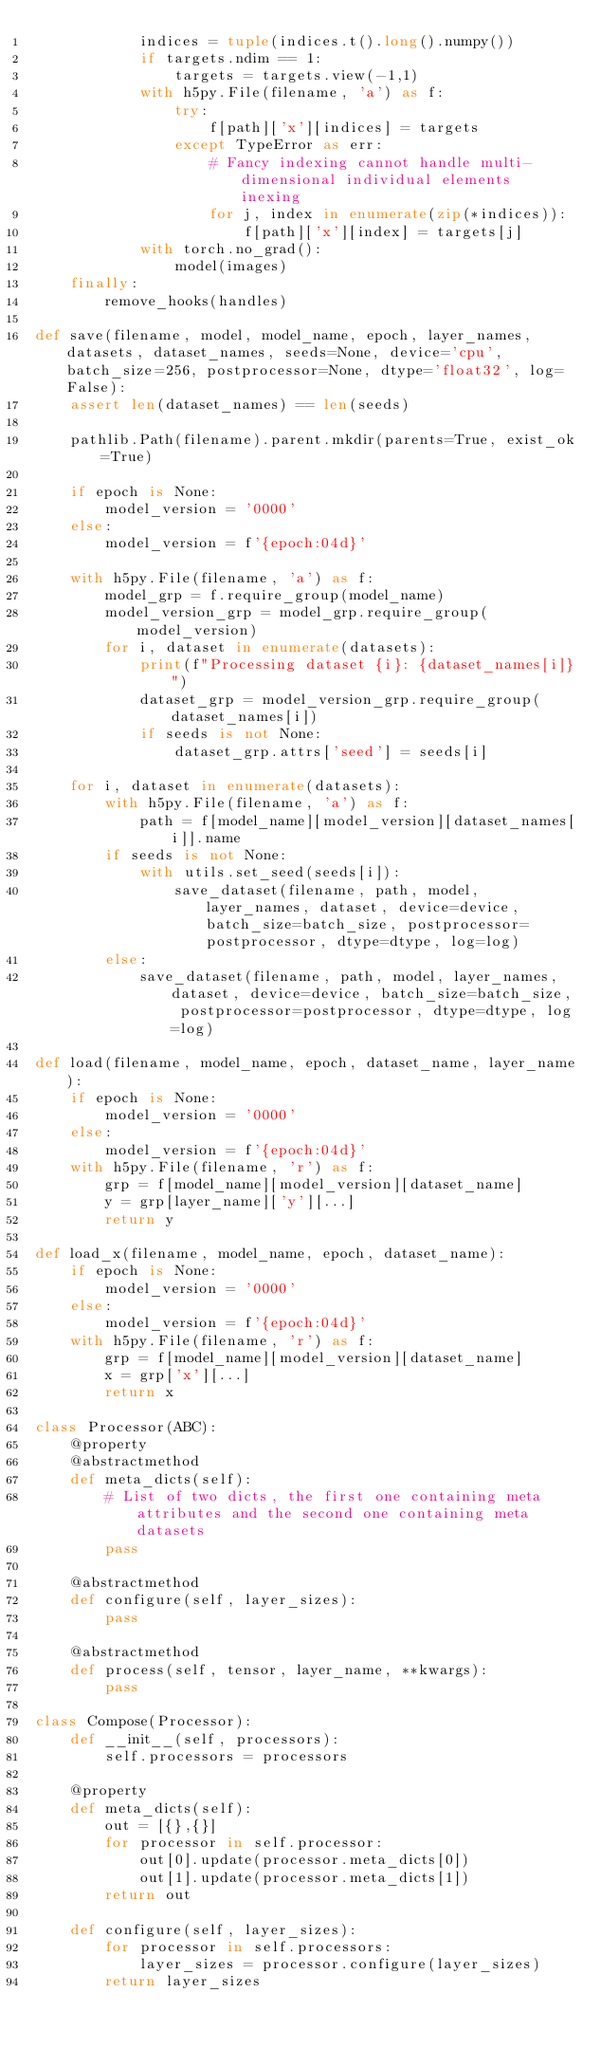<code> <loc_0><loc_0><loc_500><loc_500><_Python_>            indices = tuple(indices.t().long().numpy())
            if targets.ndim == 1:
                targets = targets.view(-1,1)
            with h5py.File(filename, 'a') as f:
                try:
                    f[path]['x'][indices] = targets
                except TypeError as err:
                    # Fancy indexing cannot handle multi-dimensional individual elements inexing
                    for j, index in enumerate(zip(*indices)):
                        f[path]['x'][index] = targets[j]
            with torch.no_grad():
                model(images)
    finally:
        remove_hooks(handles)
            
def save(filename, model, model_name, epoch, layer_names, datasets, dataset_names, seeds=None, device='cpu', batch_size=256, postprocessor=None, dtype='float32', log=False):
    assert len(dataset_names) == len(seeds)
    
    pathlib.Path(filename).parent.mkdir(parents=True, exist_ok=True)
    
    if epoch is None:
        model_version = '0000'
    else:
        model_version = f'{epoch:04d}'
    
    with h5py.File(filename, 'a') as f:
        model_grp = f.require_group(model_name)
        model_version_grp = model_grp.require_group(model_version)
        for i, dataset in enumerate(datasets):
            print(f"Processing dataset {i}: {dataset_names[i]}")
            dataset_grp = model_version_grp.require_group(dataset_names[i])
            if seeds is not None:
                dataset_grp.attrs['seed'] = seeds[i]
                
    for i, dataset in enumerate(datasets):
        with h5py.File(filename, 'a') as f:
            path = f[model_name][model_version][dataset_names[i]].name
        if seeds is not None:
            with utils.set_seed(seeds[i]):
                save_dataset(filename, path, model, layer_names, dataset, device=device, batch_size=batch_size, postprocessor=postprocessor, dtype=dtype, log=log)
        else:
            save_dataset(filename, path, model, layer_names, dataset, device=device, batch_size=batch_size, postprocessor=postprocessor, dtype=dtype, log=log)
            
def load(filename, model_name, epoch, dataset_name, layer_name):
    if epoch is None:
        model_version = '0000'
    else:
        model_version = f'{epoch:04d}'
    with h5py.File(filename, 'r') as f:
        grp = f[model_name][model_version][dataset_name]
        y = grp[layer_name]['y'][...]
        return y
    
def load_x(filename, model_name, epoch, dataset_name):
    if epoch is None:
        model_version = '0000'
    else:
        model_version = f'{epoch:04d}'
    with h5py.File(filename, 'r') as f:
        grp = f[model_name][model_version][dataset_name]
        x = grp['x'][...]
        return x
    
class Processor(ABC):
    @property
    @abstractmethod
    def meta_dicts(self):
        # List of two dicts, the first one containing meta attributes and the second one containing meta datasets
        pass
    
    @abstractmethod
    def configure(self, layer_sizes):
        pass
    
    @abstractmethod
    def process(self, tensor, layer_name, **kwargs):
        pass

class Compose(Processor):
    def __init__(self, processors):
        self.processors = processors
        
    @property
    def meta_dicts(self):
        out = [{},{}]
        for processor in self.processor:
            out[0].update(processor.meta_dicts[0])
            out[1].update(processor.meta_dicts[1])
        return out
    
    def configure(self, layer_sizes):
        for processor in self.processors:
            layer_sizes = processor.configure(layer_sizes)
        return layer_sizes
            </code> 